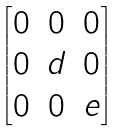<formula> <loc_0><loc_0><loc_500><loc_500>\begin{bmatrix} 0 & 0 & 0 \\ 0 & d & 0 \\ 0 & 0 & e \end{bmatrix}</formula> 